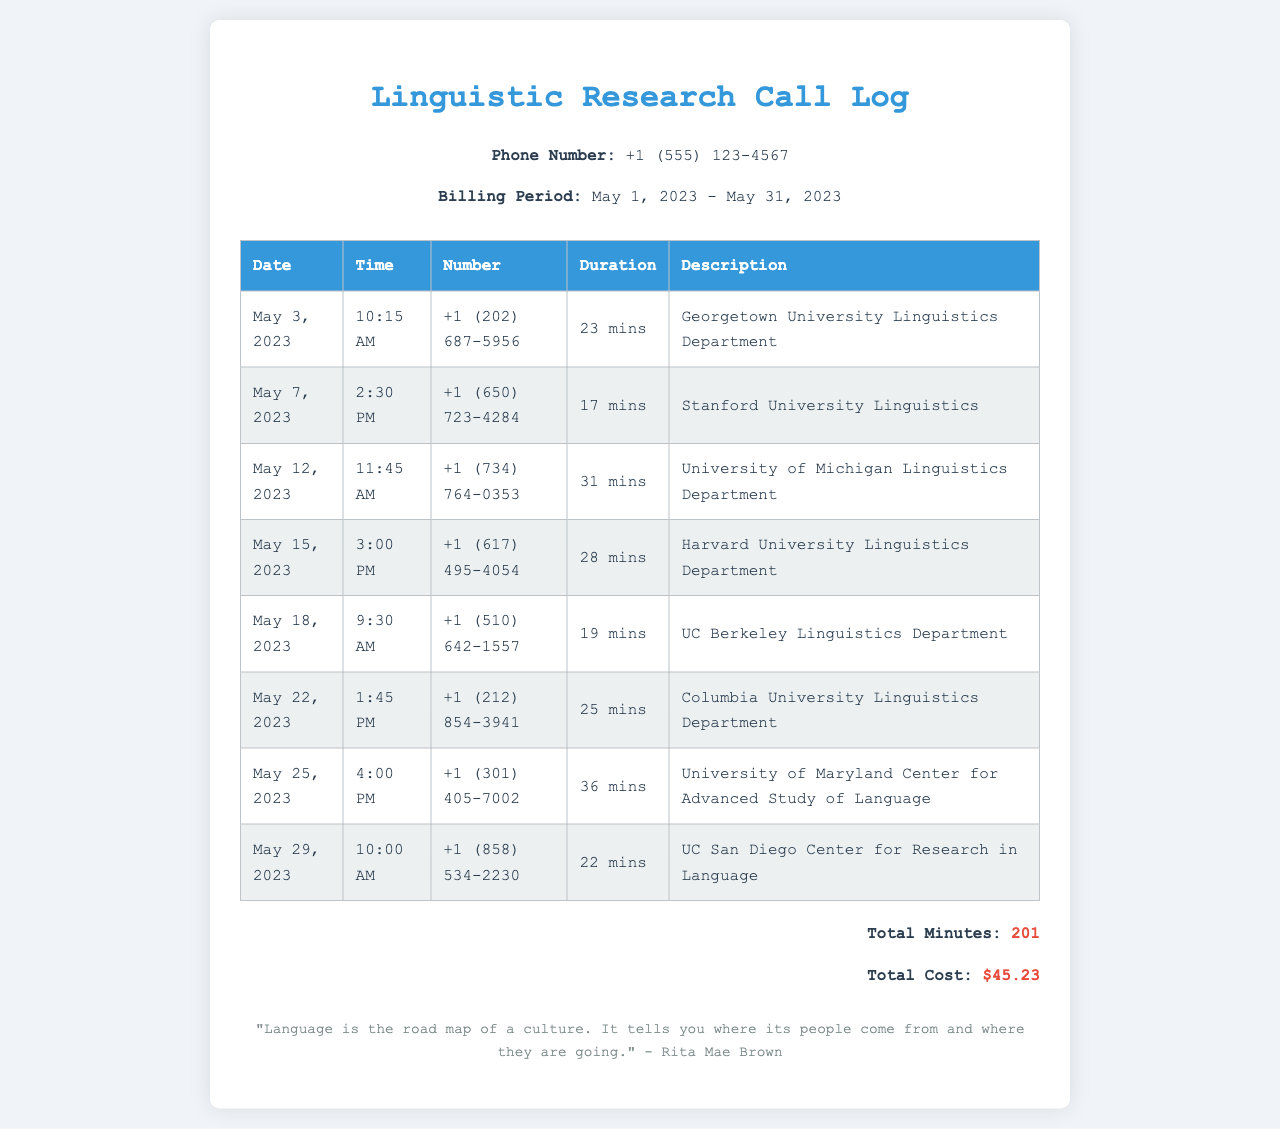What is the total number of calls made? The total number of calls can be counted from the call log entries, which has 8 calls listed.
Answer: 8 Which university's linguistics department was called on May 7, 2023? The call log indicates that on May 7, 2023, calls were made to Stanford University Linguistics.
Answer: Stanford University Linguistics How long was the call to the University of Maryland? The duration of the call to the University of Maryland, as seen in the log, was 36 minutes.
Answer: 36 mins What is the cost of the total call duration? The total cost of all calls in the document is provided as $45.23.
Answer: $45.23 On what date was the longest call made? By reviewing the call durations, the longest call at 36 minutes was made on May 25, 2023.
Answer: May 25, 2023 What is the phone number associated with the Harvard University Linguistics Department? The document lists the phone number for Harvard University Linguistics as +1 (617) 495-4054.
Answer: +1 (617) 495-4054 How many calls were made to California universities? There were two calls: one to Stanford University and another to UC Berkeley, making a total of 2 calls to California universities.
Answer: 2 What was the total call duration for the calls in the log? The cumulative duration of all calls equals 201 minutes, as presented in the summary at the bottom of the document.
Answer: 201 